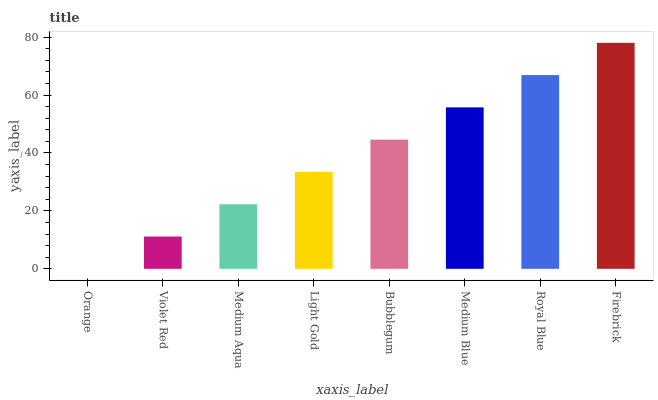Is Orange the minimum?
Answer yes or no. Yes. Is Firebrick the maximum?
Answer yes or no. Yes. Is Violet Red the minimum?
Answer yes or no. No. Is Violet Red the maximum?
Answer yes or no. No. Is Violet Red greater than Orange?
Answer yes or no. Yes. Is Orange less than Violet Red?
Answer yes or no. Yes. Is Orange greater than Violet Red?
Answer yes or no. No. Is Violet Red less than Orange?
Answer yes or no. No. Is Bubblegum the high median?
Answer yes or no. Yes. Is Light Gold the low median?
Answer yes or no. Yes. Is Orange the high median?
Answer yes or no. No. Is Bubblegum the low median?
Answer yes or no. No. 